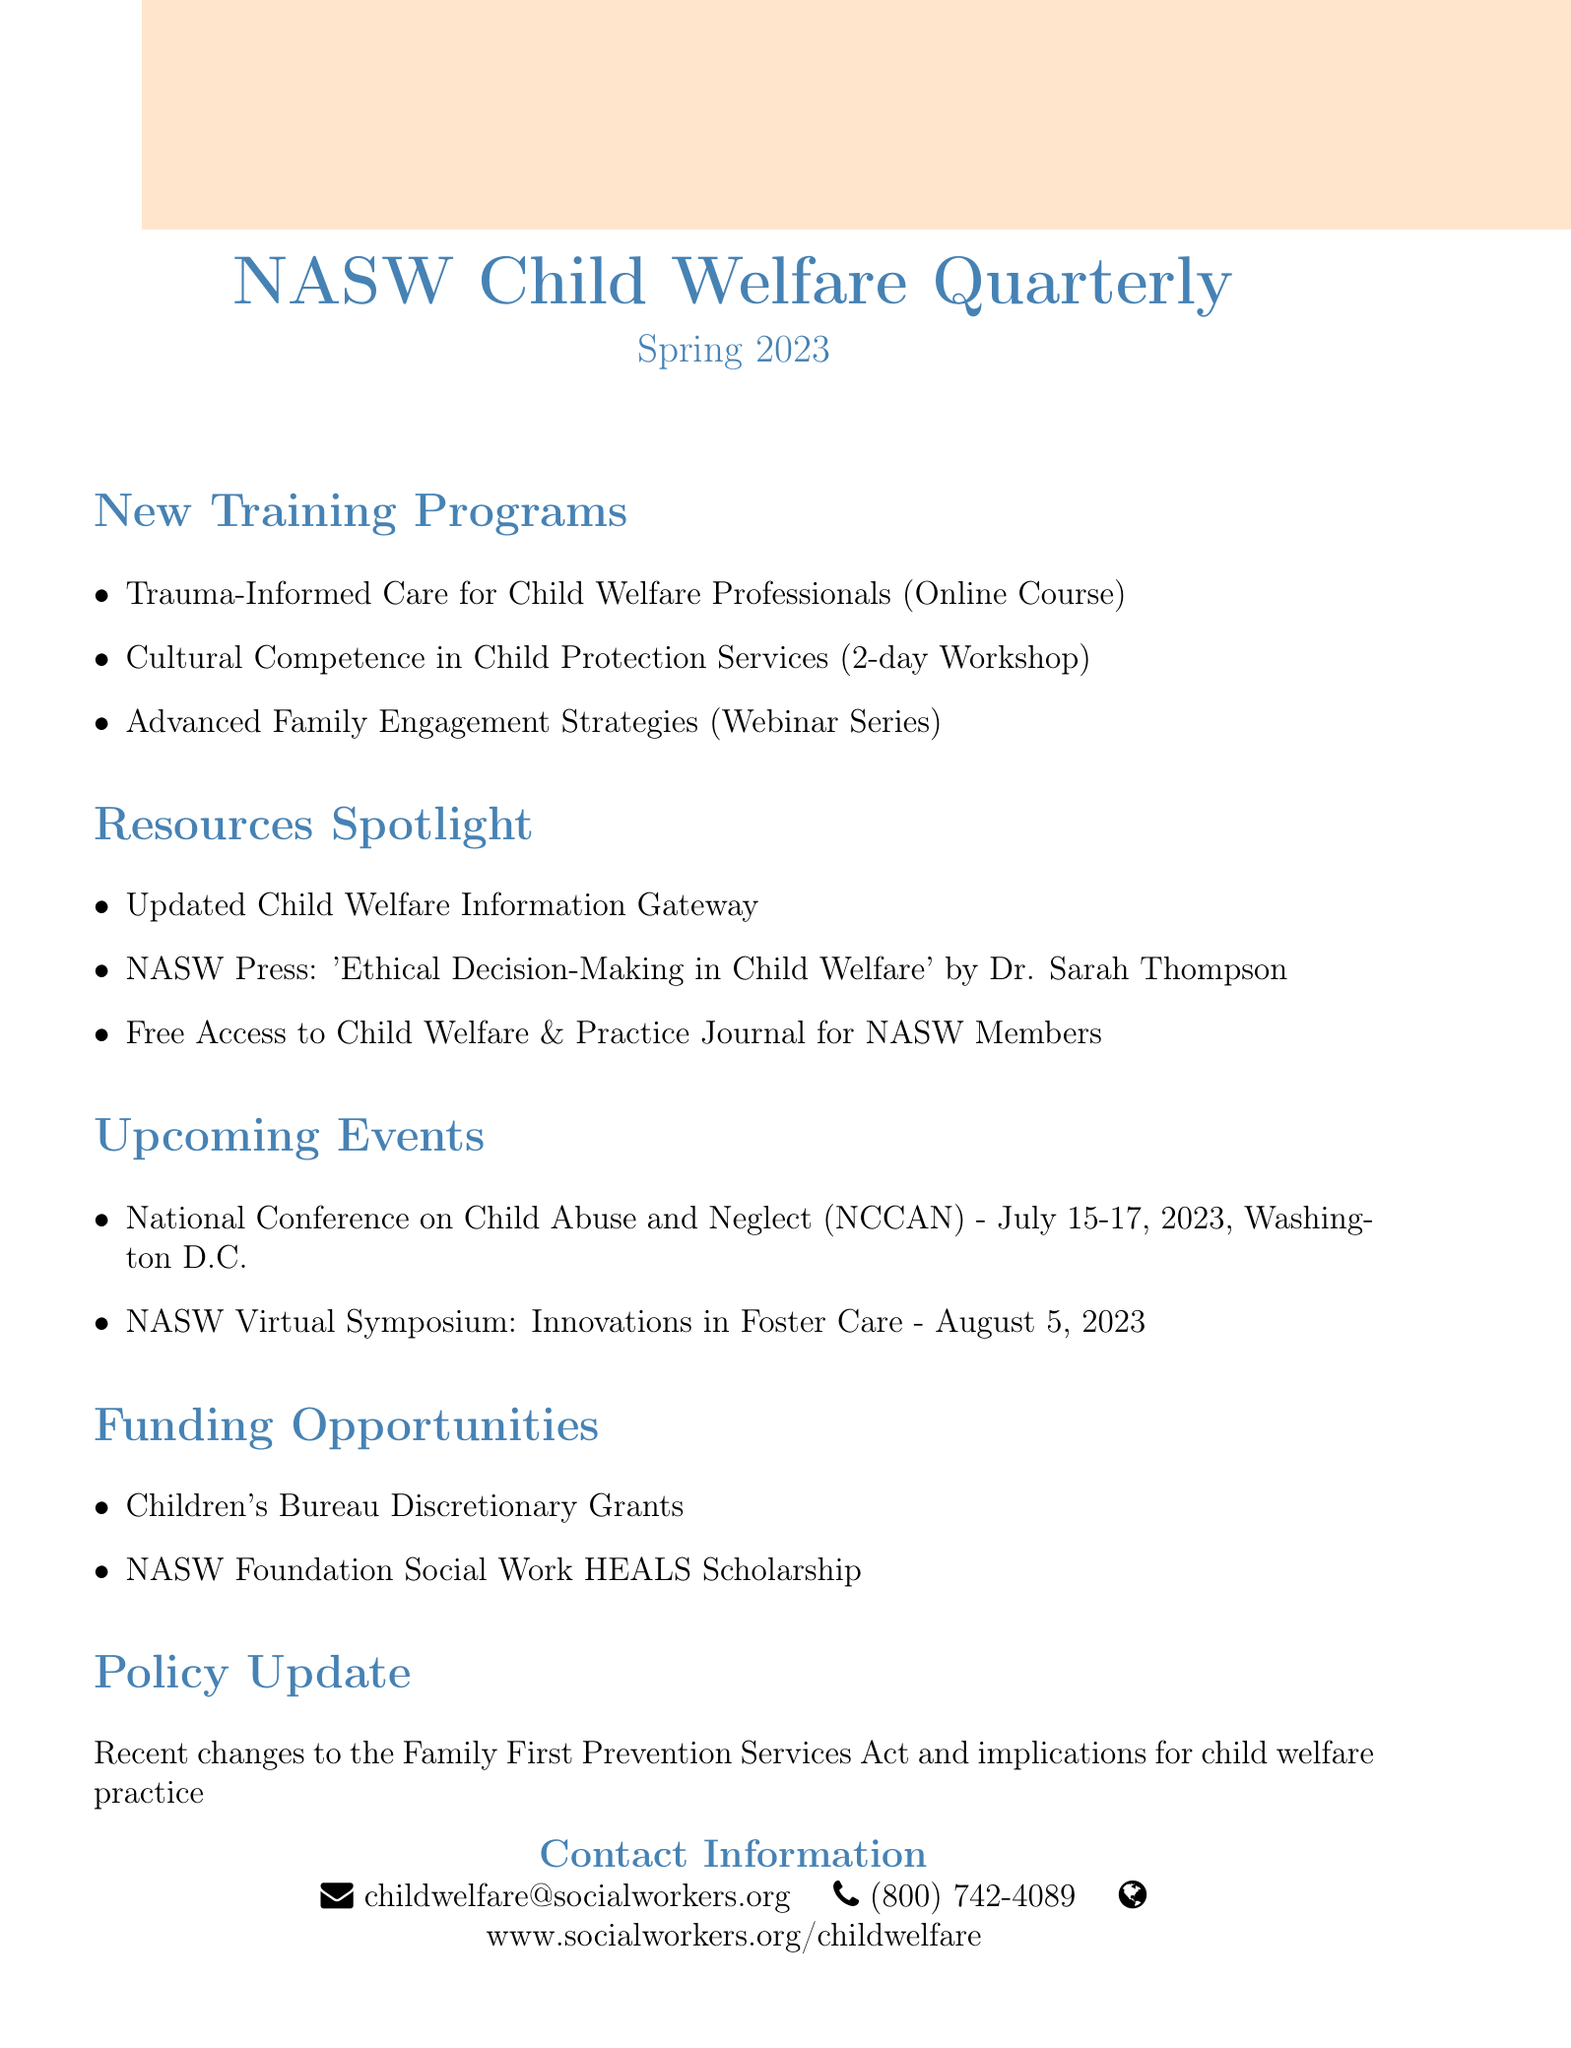What is the title of the newsletter? The title of the newsletter is stated at the beginning of the document.
Answer: NASW Child Welfare Quarterly When was the issue published? The issue date appears prominently within the document.
Answer: Spring 2023 What are the training programs listed? The section on training programs provides a list of three specific programs.
Answer: Trauma-Informed Care for Child Welfare Professionals, Cultural Competence in Child Protection Services, Advanced Family Engagement Strategies What is the date of the National Conference on Child Abuse and Neglect? The date for the upcoming event is explicitly mentioned in the document.
Answer: July 15-17, 2023 What funding opportunity is mentioned? The document outlines two specific funding opportunities available for child welfare professionals.
Answer: Children's Bureau Discretionary Grants What is the title of the book highlighted in the Resources Spotlight section? This is a specific detail in the Resources Spotlight section, which names a book.
Answer: Ethical Decision-Making in Child Welfare What recent policy update is mentioned? The document mentions a significant change in policy that impacts child welfare practice.
Answer: Family First Prevention Services Act How can you contact the National Association of Social Workers for child welfare inquiries? Contact information is specifically provided at the end of the document.
Answer: childwelfare@socialworkers.org What is a theme of the upcoming NASW Virtual Symposium? The theme of the virtual symposium is detailed within the Upcoming Events section.
Answer: Innovations in Foster Care 